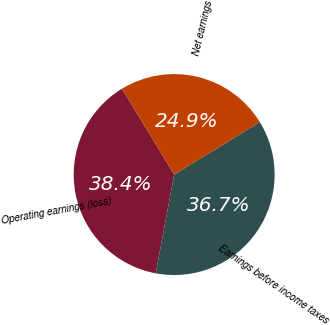<chart> <loc_0><loc_0><loc_500><loc_500><pie_chart><fcel>Operating earnings (loss)<fcel>Earnings before income taxes<fcel>Net earnings<nl><fcel>38.37%<fcel>36.69%<fcel>24.94%<nl></chart> 